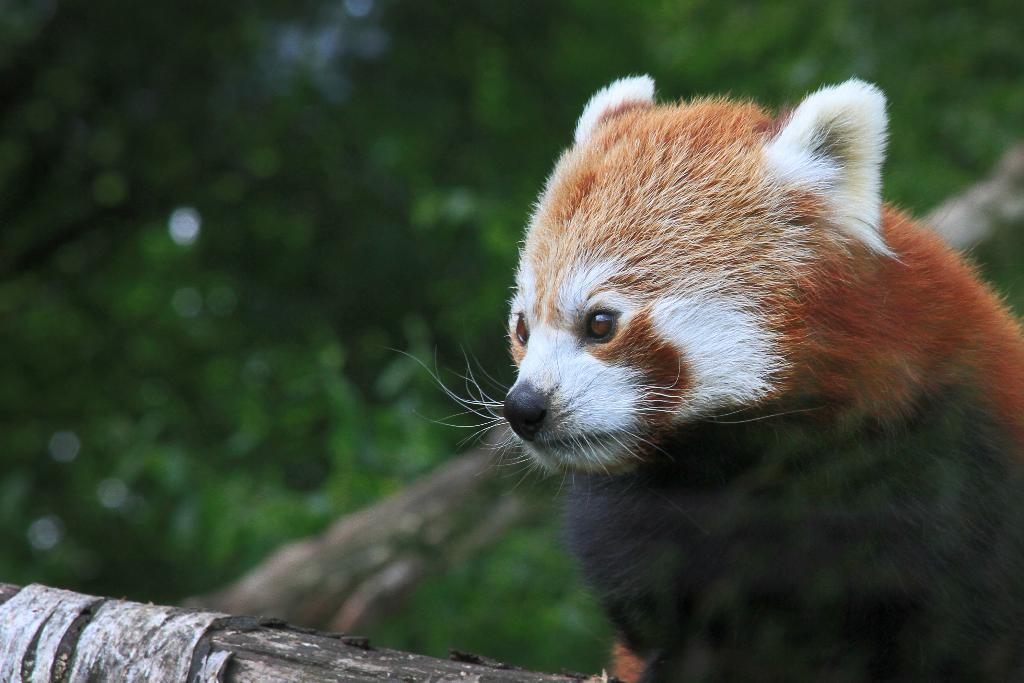Describe this image in one or two sentences. This picture is clicked outside. On the right we can see a red panda and we can see the branches of the trees. In the background we can see the green leaves. 